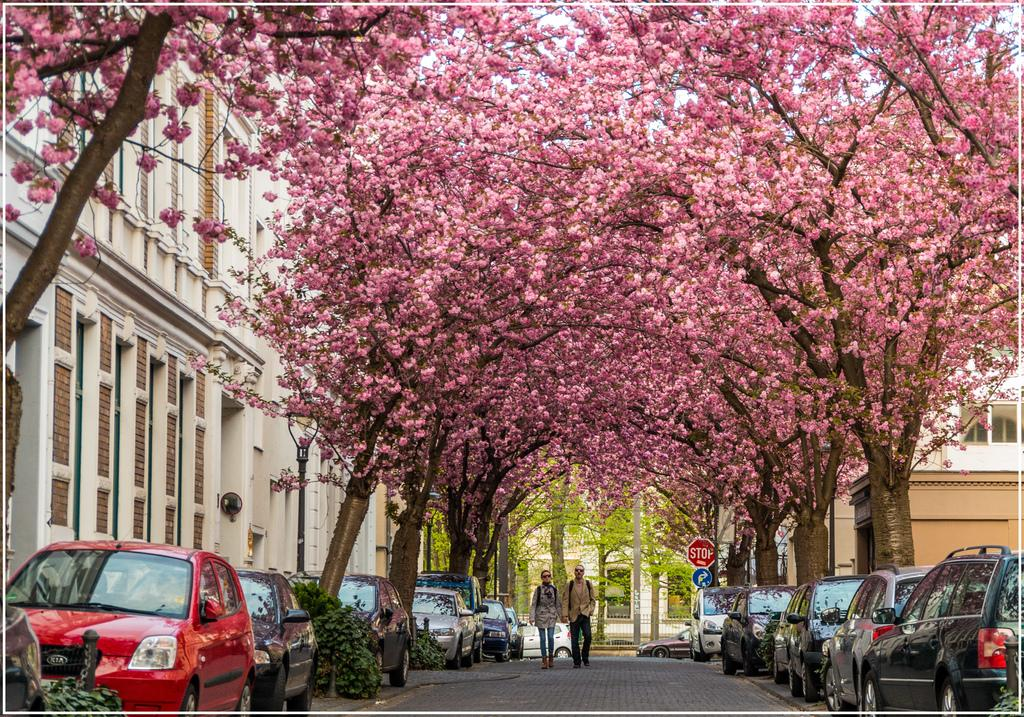What are the people in the image doing? There are persons walking on the road in the image. What else can be seen on the road? Cars are present on the road. What type of natural elements are present on the sides of the road? Trees are on either side of the road. What can be seen in the distance behind the road? Buildings are visible in the background. What type of bread is being sold at the vegetable stand in the image? There is no vegetable stand or bread present in the image. 